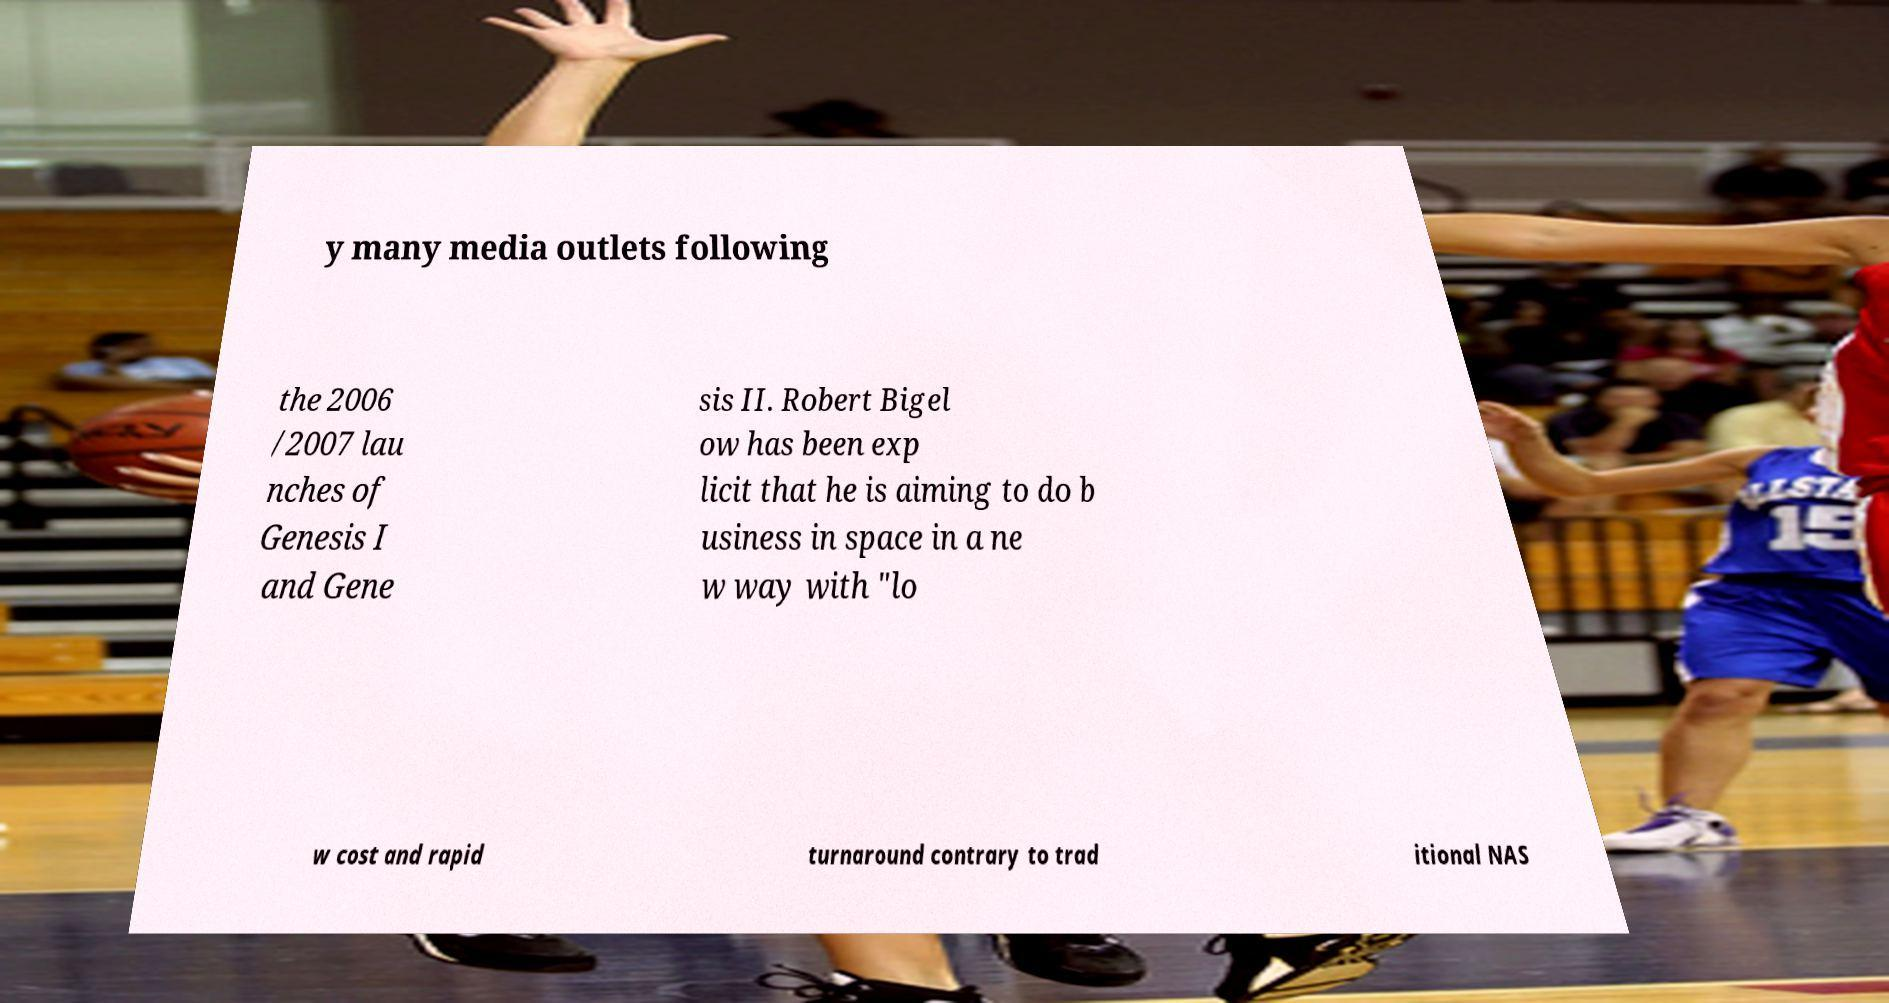What messages or text are displayed in this image? I need them in a readable, typed format. y many media outlets following the 2006 /2007 lau nches of Genesis I and Gene sis II. Robert Bigel ow has been exp licit that he is aiming to do b usiness in space in a ne w way with "lo w cost and rapid turnaround contrary to trad itional NAS 